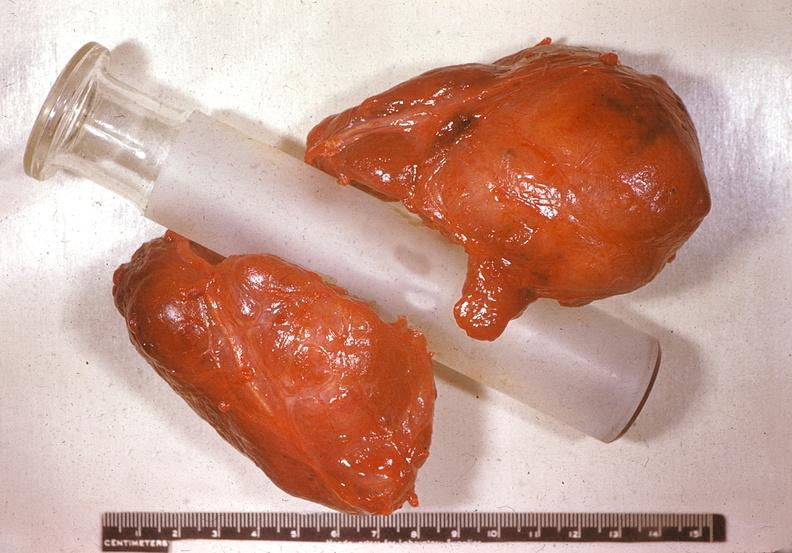where does this belong to?
Answer the question using a single word or phrase. Endocrine system 